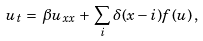Convert formula to latex. <formula><loc_0><loc_0><loc_500><loc_500>u _ { t } \, = \, \beta u _ { x x } \, + \, \sum _ { i } \delta ( x - i ) f ( u ) \, ,</formula> 